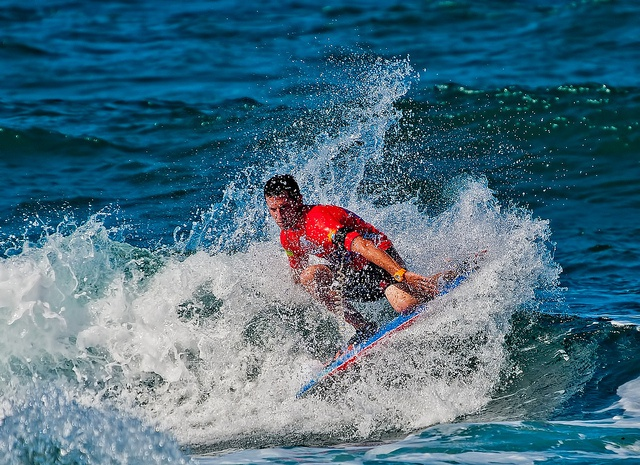Describe the objects in this image and their specific colors. I can see people in blue, black, darkgray, gray, and maroon tones and surfboard in blue, darkgray, gray, and lightgray tones in this image. 